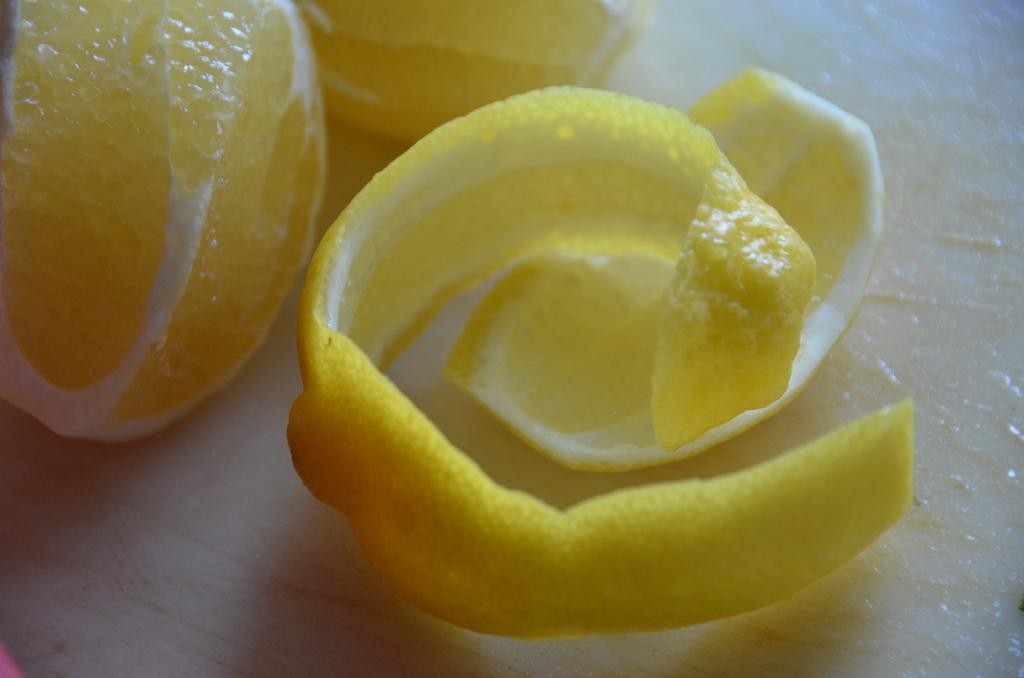What part of a lemon can be seen in the image? The pulp and peel of a lemon can be seen in the image. What is the relationship between the lemon pulp and peel in the image? The lemon pulp and peel are both present in the image, and they are likely from the same lemon. On what object are the lemon pulp and peel placed in the image? The lemon pulp and peel are on an object, but the specific object is not mentioned in the provided facts. What type of credit card is shown in the image? There is no credit card present in the image; it features the pulp and peel of a lemon. What role does the father play in the image? There is no father or any human figure present in the image; it only features the pulp and peel of a lemon. 